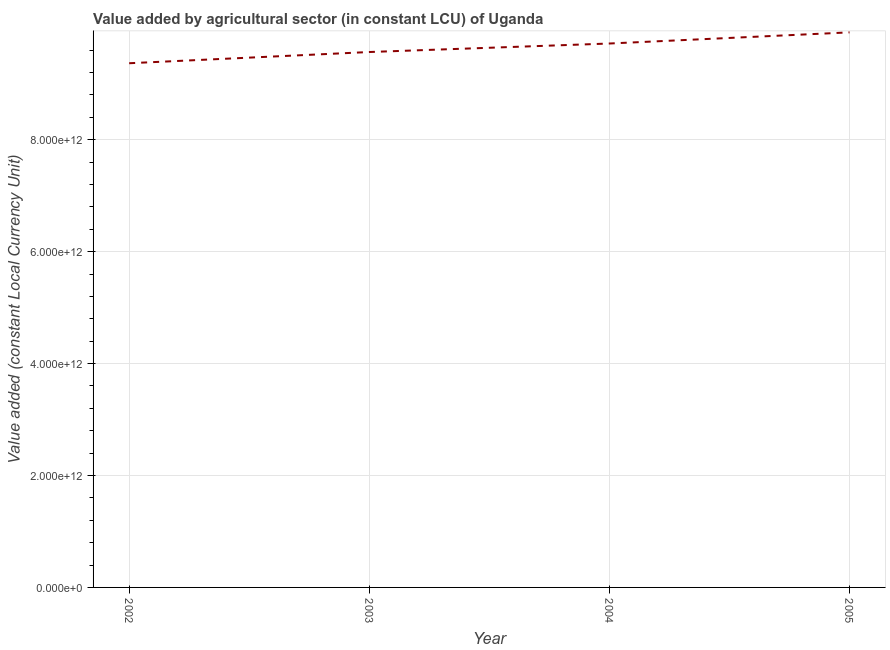What is the value added by agriculture sector in 2004?
Provide a succinct answer. 9.72e+12. Across all years, what is the maximum value added by agriculture sector?
Your response must be concise. 9.92e+12. Across all years, what is the minimum value added by agriculture sector?
Your response must be concise. 9.37e+12. In which year was the value added by agriculture sector maximum?
Your response must be concise. 2005. In which year was the value added by agriculture sector minimum?
Offer a terse response. 2002. What is the sum of the value added by agriculture sector?
Your answer should be compact. 3.86e+13. What is the difference between the value added by agriculture sector in 2002 and 2003?
Make the answer very short. -2.00e+11. What is the average value added by agriculture sector per year?
Give a very brief answer. 9.64e+12. What is the median value added by agriculture sector?
Ensure brevity in your answer.  9.64e+12. Do a majority of the years between 2004 and 2003 (inclusive) have value added by agriculture sector greater than 6800000000000 LCU?
Ensure brevity in your answer.  No. What is the ratio of the value added by agriculture sector in 2002 to that in 2004?
Provide a succinct answer. 0.96. Is the value added by agriculture sector in 2003 less than that in 2004?
Keep it short and to the point. Yes. What is the difference between the highest and the second highest value added by agriculture sector?
Offer a terse response. 1.99e+11. Is the sum of the value added by agriculture sector in 2003 and 2005 greater than the maximum value added by agriculture sector across all years?
Your answer should be very brief. Yes. What is the difference between the highest and the lowest value added by agriculture sector?
Give a very brief answer. 5.52e+11. In how many years, is the value added by agriculture sector greater than the average value added by agriculture sector taken over all years?
Ensure brevity in your answer.  2. Does the value added by agriculture sector monotonically increase over the years?
Give a very brief answer. Yes. How many lines are there?
Offer a terse response. 1. How many years are there in the graph?
Your response must be concise. 4. What is the difference between two consecutive major ticks on the Y-axis?
Your answer should be very brief. 2.00e+12. Are the values on the major ticks of Y-axis written in scientific E-notation?
Give a very brief answer. Yes. Does the graph contain grids?
Provide a succinct answer. Yes. What is the title of the graph?
Provide a succinct answer. Value added by agricultural sector (in constant LCU) of Uganda. What is the label or title of the Y-axis?
Provide a succinct answer. Value added (constant Local Currency Unit). What is the Value added (constant Local Currency Unit) of 2002?
Your answer should be very brief. 9.37e+12. What is the Value added (constant Local Currency Unit) of 2003?
Keep it short and to the point. 9.57e+12. What is the Value added (constant Local Currency Unit) in 2004?
Make the answer very short. 9.72e+12. What is the Value added (constant Local Currency Unit) in 2005?
Your answer should be compact. 9.92e+12. What is the difference between the Value added (constant Local Currency Unit) in 2002 and 2003?
Your response must be concise. -2.00e+11. What is the difference between the Value added (constant Local Currency Unit) in 2002 and 2004?
Offer a terse response. -3.52e+11. What is the difference between the Value added (constant Local Currency Unit) in 2002 and 2005?
Provide a short and direct response. -5.52e+11. What is the difference between the Value added (constant Local Currency Unit) in 2003 and 2004?
Provide a succinct answer. -1.52e+11. What is the difference between the Value added (constant Local Currency Unit) in 2003 and 2005?
Make the answer very short. -3.51e+11. What is the difference between the Value added (constant Local Currency Unit) in 2004 and 2005?
Offer a terse response. -1.99e+11. What is the ratio of the Value added (constant Local Currency Unit) in 2002 to that in 2004?
Keep it short and to the point. 0.96. What is the ratio of the Value added (constant Local Currency Unit) in 2002 to that in 2005?
Offer a terse response. 0.94. What is the ratio of the Value added (constant Local Currency Unit) in 2003 to that in 2005?
Ensure brevity in your answer.  0.96. 